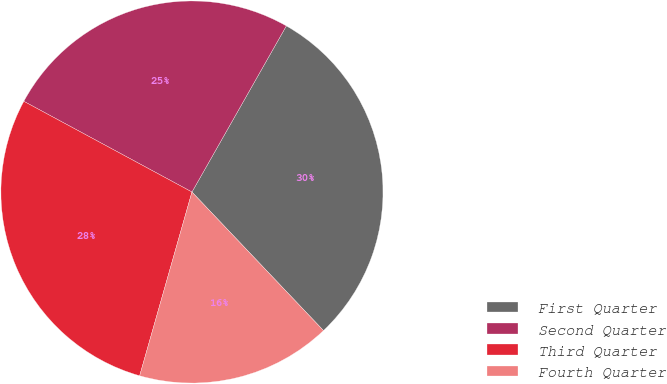Convert chart to OTSL. <chart><loc_0><loc_0><loc_500><loc_500><pie_chart><fcel>First Quarter<fcel>Second Quarter<fcel>Third Quarter<fcel>Fourth Quarter<nl><fcel>29.69%<fcel>25.35%<fcel>28.46%<fcel>16.5%<nl></chart> 